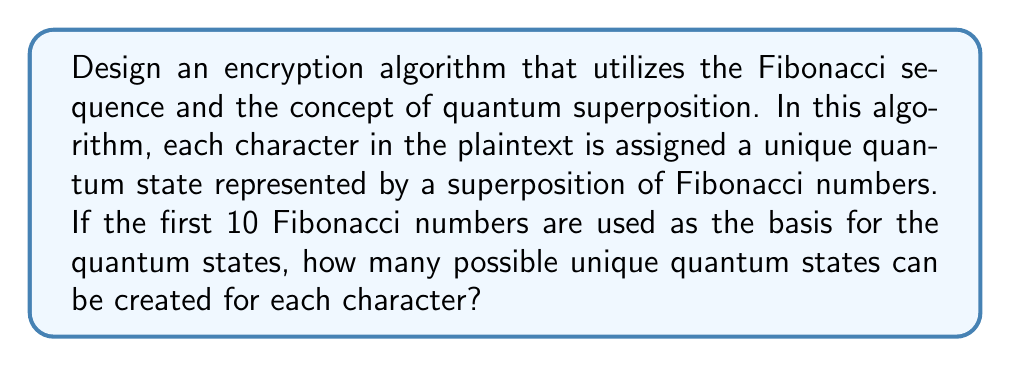Could you help me with this problem? To solve this problem, we need to think creatively and combine concepts from number theory and quantum mechanics. Let's break it down step-by-step:

1. Recall the first 10 Fibonacci numbers:
   $F_1 = 1, F_2 = 1, F_3 = 2, F_4 = 3, F_5 = 5, F_6 = 8, F_7 = 13, F_8 = 21, F_9 = 34, F_{10} = 55$

2. In quantum superposition, a quantum state can exist in multiple states simultaneously. We'll represent each character as a superposition of these 10 Fibonacci numbers.

3. For each Fibonacci number, we have two choices: include it in the superposition or not. This is similar to having 10 independent quantum bits (qubits).

4. The number of possible combinations for n independent binary choices is given by $2^n$.

5. In this case, we have 10 choices (one for each Fibonacci number), so the total number of possible unique quantum states is:

   $$2^{10} = 1024$$

6. This means that each character in the plaintext can be encoded into one of 1024 possible quantum states, creating a large space for encryption.

7. The encryption process would involve mapping each character to a unique superposition of Fibonacci numbers, while decryption would involve measuring the quantum state and mapping it back to the original character.
Answer: 1024 